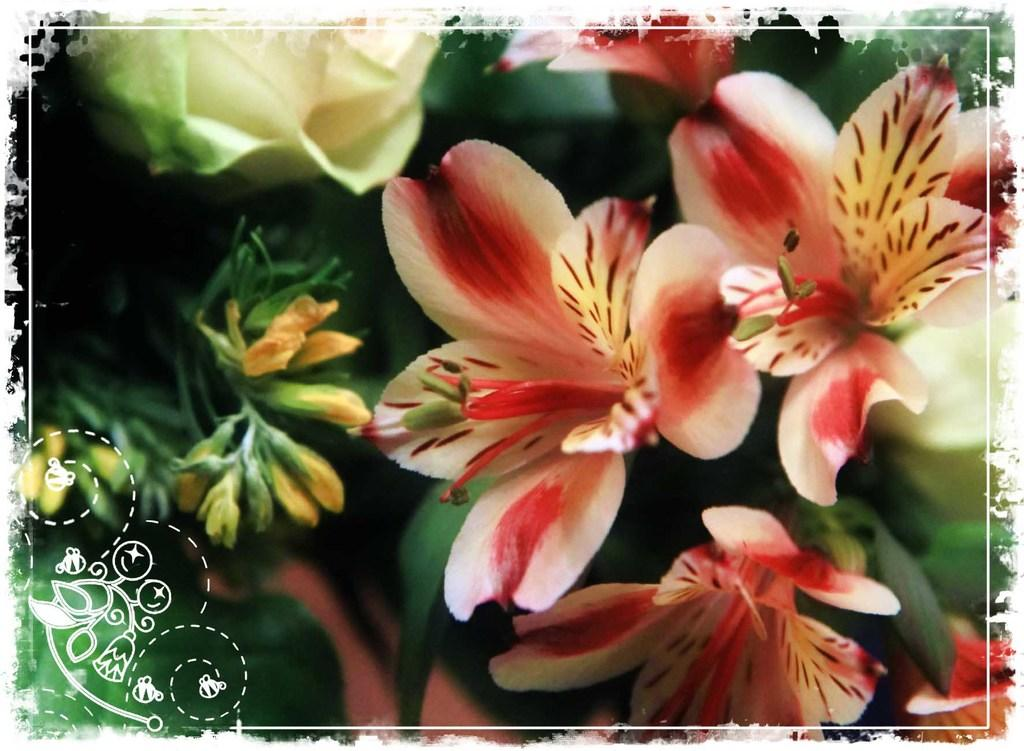What type of living organisms can be seen in the image? There are flowers in the image. Can you describe the colors of the flowers? The flowers have various colors, including cream, green, red, black, and orange. What color are the plants in the image? The plants in the image are green in color. How many trucks does the wealthiest person in the image own? There is no information about wealth or trucks in the image, as it only features flowers and plants. 